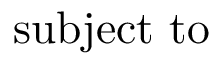<formula> <loc_0><loc_0><loc_500><loc_500>s u b j e c t t o</formula> 